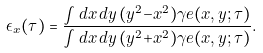<formula> <loc_0><loc_0><loc_500><loc_500>\epsilon _ { x } ( \tau ) = \frac { \int d x \, d y \, ( y ^ { 2 } { - } x ^ { 2 } ) \gamma e ( x , y ; \tau ) } { \int d x \, d y \, ( y ^ { 2 } { + } x ^ { 2 } ) \gamma e ( x , y ; \tau ) } .</formula> 